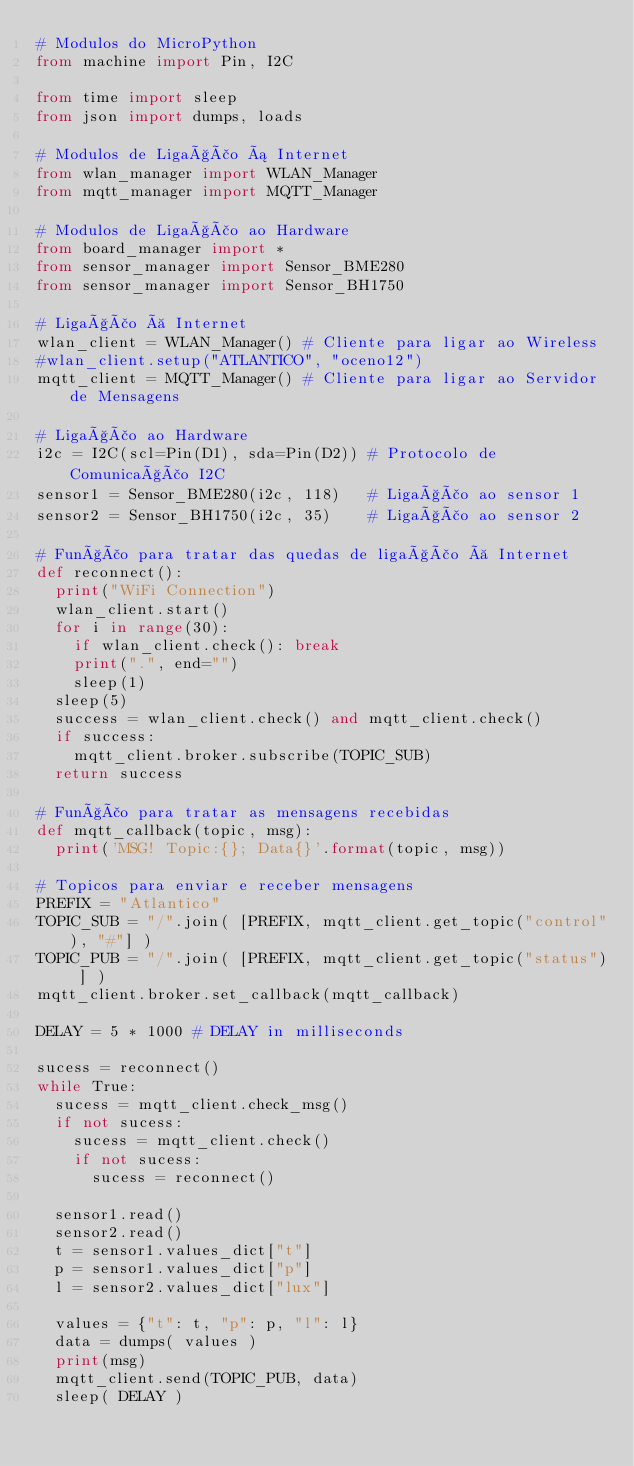<code> <loc_0><loc_0><loc_500><loc_500><_Python_># Modulos do MicroPython
from machine import Pin, I2C

from time import sleep
from json import dumps, loads

# Modulos de Ligação á Internet
from wlan_manager import WLAN_Manager
from mqtt_manager import MQTT_Manager

# Modulos de Ligação ao Hardware
from board_manager import *
from sensor_manager import Sensor_BME280
from sensor_manager import Sensor_BH1750

# Ligação à Internet
wlan_client = WLAN_Manager() # Cliente para ligar ao Wireless
#wlan_client.setup("ATLANTICO", "oceno12")
mqtt_client = MQTT_Manager() # Cliente para ligar ao Servidor de Mensagens

# Ligação ao Hardware
i2c = I2C(scl=Pin(D1), sda=Pin(D2)) # Protocolo de Comunicação I2C
sensor1 = Sensor_BME280(i2c, 118)   # Ligação ao sensor 1
sensor2 = Sensor_BH1750(i2c, 35)    # Ligação ao sensor 2

# Função para tratar das quedas de ligação à Internet
def reconnect():
  print("WiFi Connection")
  wlan_client.start()
  for i in range(30):
    if wlan_client.check(): break
    print(".", end="")
    sleep(1)
  sleep(5)
  success = wlan_client.check() and mqtt_client.check()
  if success:
    mqtt_client.broker.subscribe(TOPIC_SUB)
  return success

# Função para tratar as mensagens recebidas
def mqtt_callback(topic, msg):
  print('MSG! Topic:{}; Data{}'.format(topic, msg))
  
# Topicos para enviar e receber mensagens
PREFIX = "Atlantico"
TOPIC_SUB = "/".join( [PREFIX, mqtt_client.get_topic("control"), "#"] )
TOPIC_PUB = "/".join( [PREFIX, mqtt_client.get_topic("status") ] )
mqtt_client.broker.set_callback(mqtt_callback)

DELAY = 5 * 1000 # DELAY in milliseconds

sucess = reconnect()
while True:
  sucess = mqtt_client.check_msg()
  if not sucess:
    sucess = mqtt_client.check()
    if not sucess: 
      sucess = reconnect()  
  
  sensor1.read()
  sensor2.read()
  t = sensor1.values_dict["t"]
  p = sensor1.values_dict["p"]
  l = sensor2.values_dict["lux"]
  
  values = {"t": t, "p": p, "l": l}
  data = dumps( values )
  print(msg)
  mqtt_client.send(TOPIC_PUB, data)
  sleep( DELAY )
</code> 